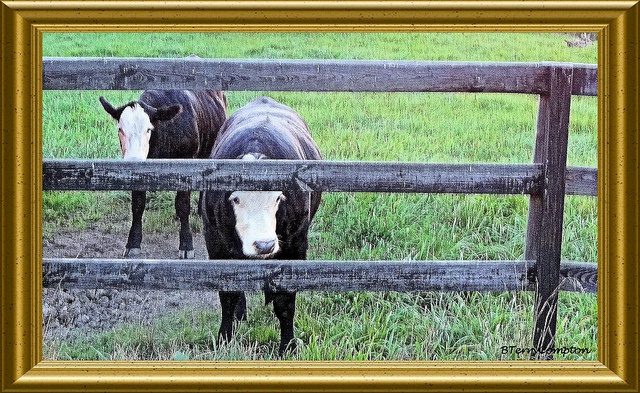Describe the objects in this image and their specific colors. I can see cow in olive, black, lavender, gray, and darkgray tones and cow in olive, black, gray, lavender, and darkgray tones in this image. 